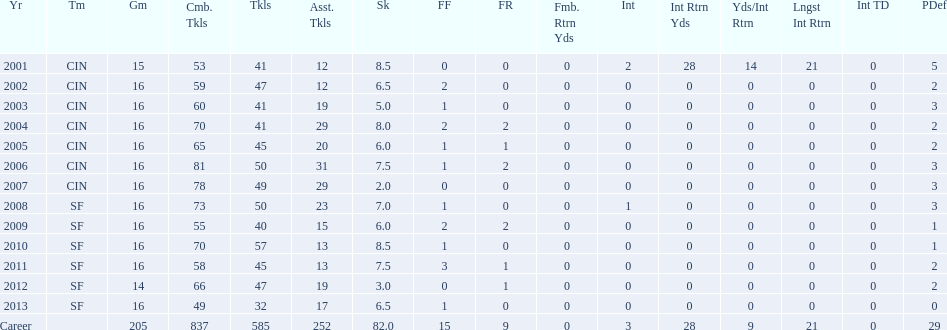What was the number of combined tackles in 2010? 70. 